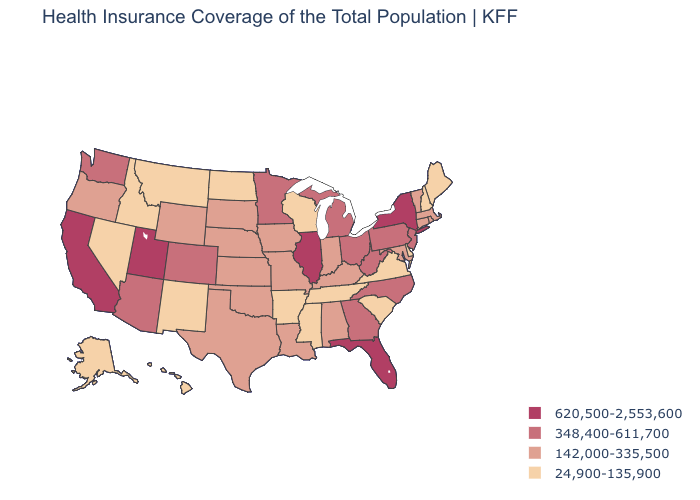Is the legend a continuous bar?
Short answer required. No. What is the lowest value in the USA?
Give a very brief answer. 24,900-135,900. Does the map have missing data?
Quick response, please. No. Among the states that border Colorado , which have the highest value?
Answer briefly. Utah. Name the states that have a value in the range 24,900-135,900?
Quick response, please. Alaska, Arkansas, Delaware, Hawaii, Idaho, Maine, Mississippi, Montana, Nevada, New Hampshire, New Mexico, North Dakota, South Carolina, Tennessee, Virginia, Wisconsin. Name the states that have a value in the range 620,500-2,553,600?
Be succinct. California, Florida, Illinois, New York, Utah. Does Indiana have a lower value than Georgia?
Write a very short answer. Yes. What is the highest value in the USA?
Give a very brief answer. 620,500-2,553,600. Name the states that have a value in the range 142,000-335,500?
Keep it brief. Alabama, Connecticut, Indiana, Iowa, Kansas, Kentucky, Louisiana, Maryland, Massachusetts, Missouri, Nebraska, Oklahoma, Oregon, Rhode Island, South Dakota, Texas, Vermont, Wyoming. Among the states that border Kentucky , which have the lowest value?
Answer briefly. Tennessee, Virginia. Does Illinois have the highest value in the USA?
Give a very brief answer. Yes. How many symbols are there in the legend?
Short answer required. 4. Name the states that have a value in the range 620,500-2,553,600?
Concise answer only. California, Florida, Illinois, New York, Utah. Name the states that have a value in the range 142,000-335,500?
Write a very short answer. Alabama, Connecticut, Indiana, Iowa, Kansas, Kentucky, Louisiana, Maryland, Massachusetts, Missouri, Nebraska, Oklahoma, Oregon, Rhode Island, South Dakota, Texas, Vermont, Wyoming. Name the states that have a value in the range 24,900-135,900?
Concise answer only. Alaska, Arkansas, Delaware, Hawaii, Idaho, Maine, Mississippi, Montana, Nevada, New Hampshire, New Mexico, North Dakota, South Carolina, Tennessee, Virginia, Wisconsin. 